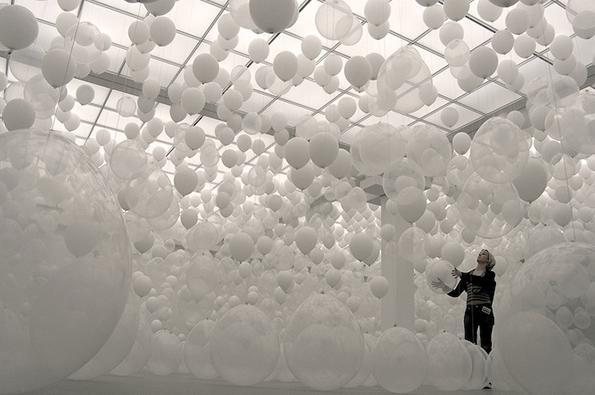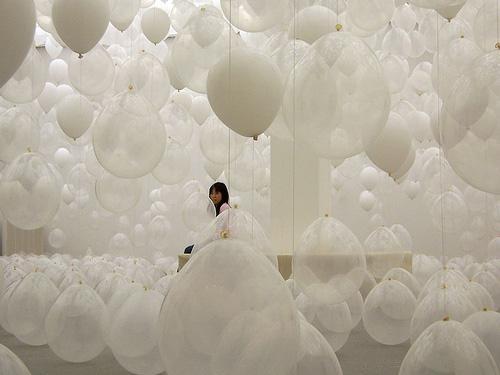The first image is the image on the left, the second image is the image on the right. Considering the images on both sides, is "There are ornaments hanging down from balloons so clear they are nearly invisible." valid? Answer yes or no. No. 